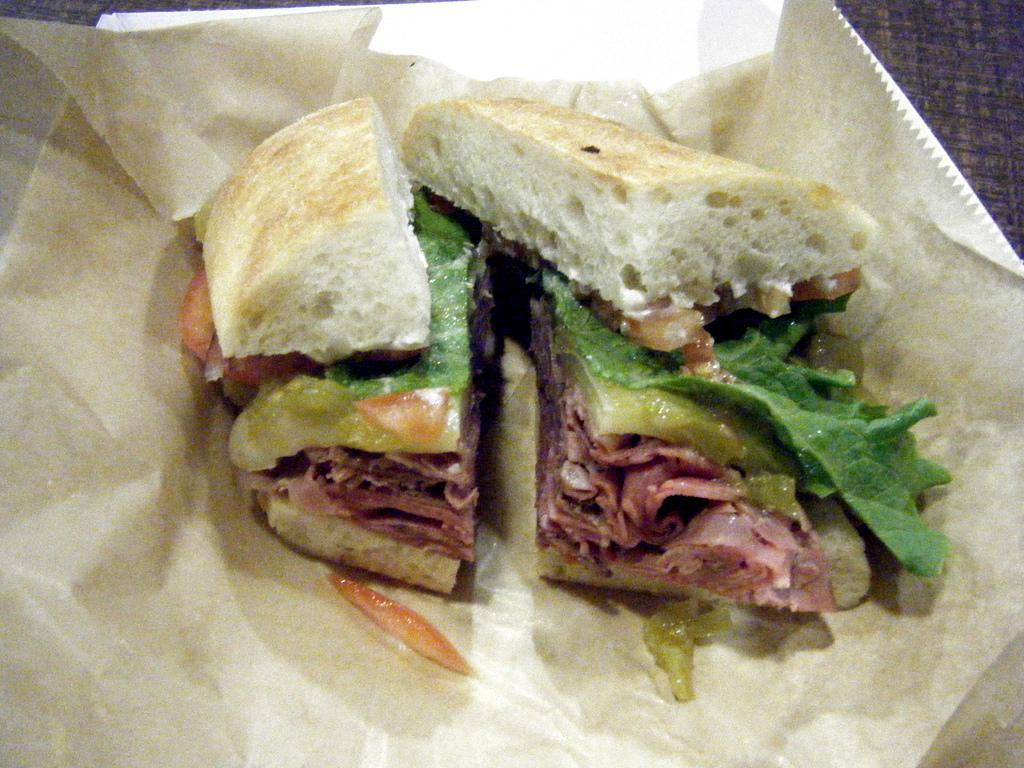In one or two sentences, can you explain what this image depicts? In this picture, we can see there are some food items on the paper and the paper is on the plate. 